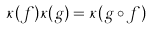Convert formula to latex. <formula><loc_0><loc_0><loc_500><loc_500>\kappa ( f ) \kappa ( g ) = \kappa ( g \circ f )</formula> 